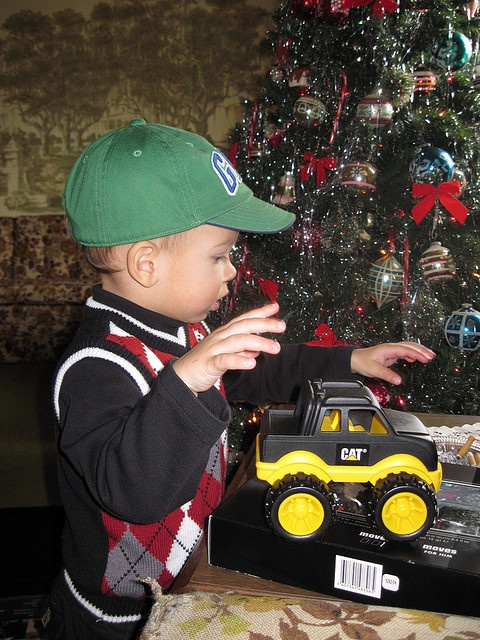Describe the objects in this image and their specific colors. I can see people in black, teal, tan, and gray tones and truck in black, gray, gold, and yellow tones in this image. 